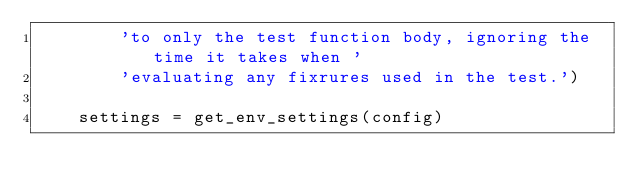<code> <loc_0><loc_0><loc_500><loc_500><_Python_>        'to only the test function body, ignoring the time it takes when '
        'evaluating any fixrures used in the test.')

    settings = get_env_settings(config)</code> 